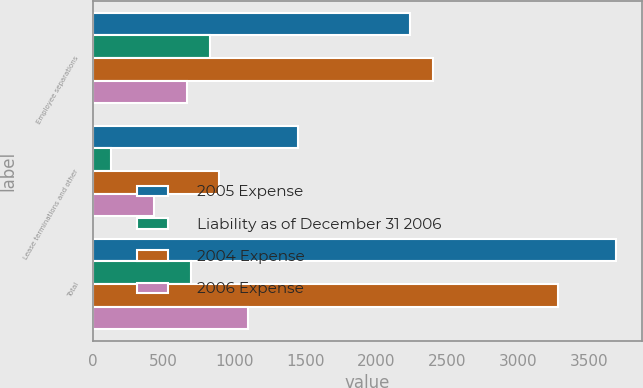<chart> <loc_0><loc_0><loc_500><loc_500><stacked_bar_chart><ecel><fcel>Employee separations<fcel>Lease terminations and other<fcel>Total<nl><fcel>2005 Expense<fcel>2239<fcel>1450<fcel>3689<nl><fcel>Liability as of December 31 2006<fcel>823<fcel>131<fcel>692<nl><fcel>2004 Expense<fcel>2397<fcel>888<fcel>3285<nl><fcel>2006 Expense<fcel>665<fcel>431<fcel>1096<nl></chart> 